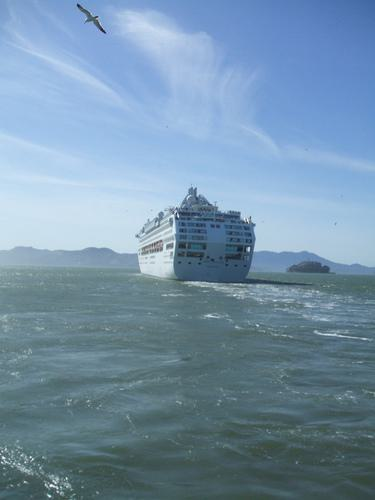Is there a boat in the image? Yes 